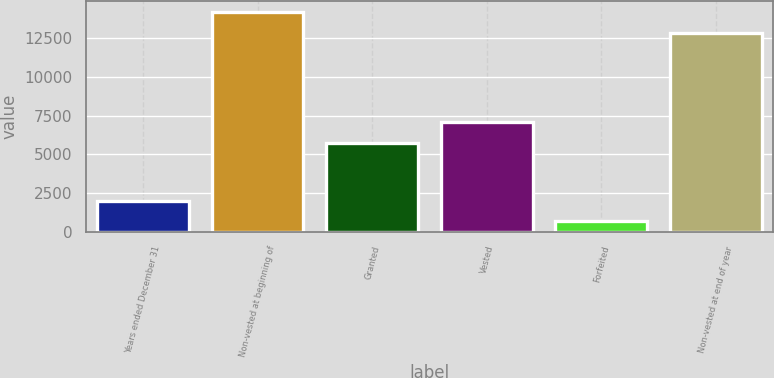<chart> <loc_0><loc_0><loc_500><loc_500><bar_chart><fcel>Years ended December 31<fcel>Non-vested at beginning of<fcel>Granted<fcel>Vested<fcel>Forfeited<fcel>Non-vested at end of year<nl><fcel>2009<fcel>14189.4<fcel>5741<fcel>7080.4<fcel>666<fcel>12850<nl></chart> 